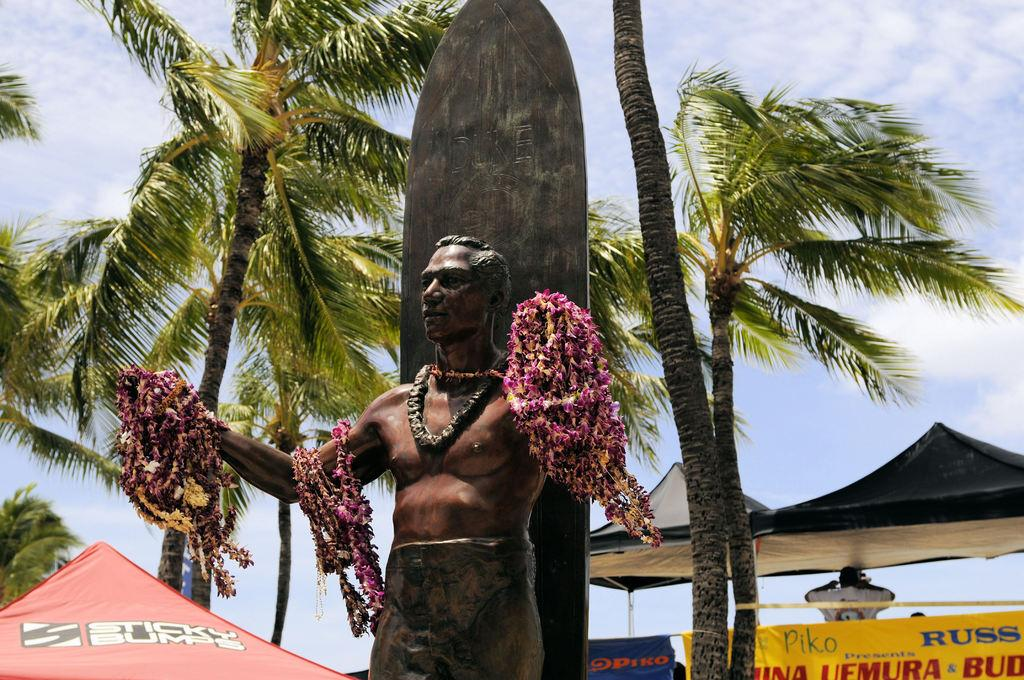What is the main subject of the image? There is a sculpture of a man in the image. What is adorning the sculpture? There are many garlands on the sculpture. What can be seen in the background of the image? There are tents and banners in the background of the image. What type of vegetation is present between the tents and banners? There are tall trees between the tents and banners. What is the root cause of the aftermath depicted in the image? There is no aftermath depicted in the image; it features a sculpture with garlands, tents, banners, and tall trees. What is the sculpture's interest in the events happening in the background? The sculpture is an inanimate object and does not have any interests or emotions. 